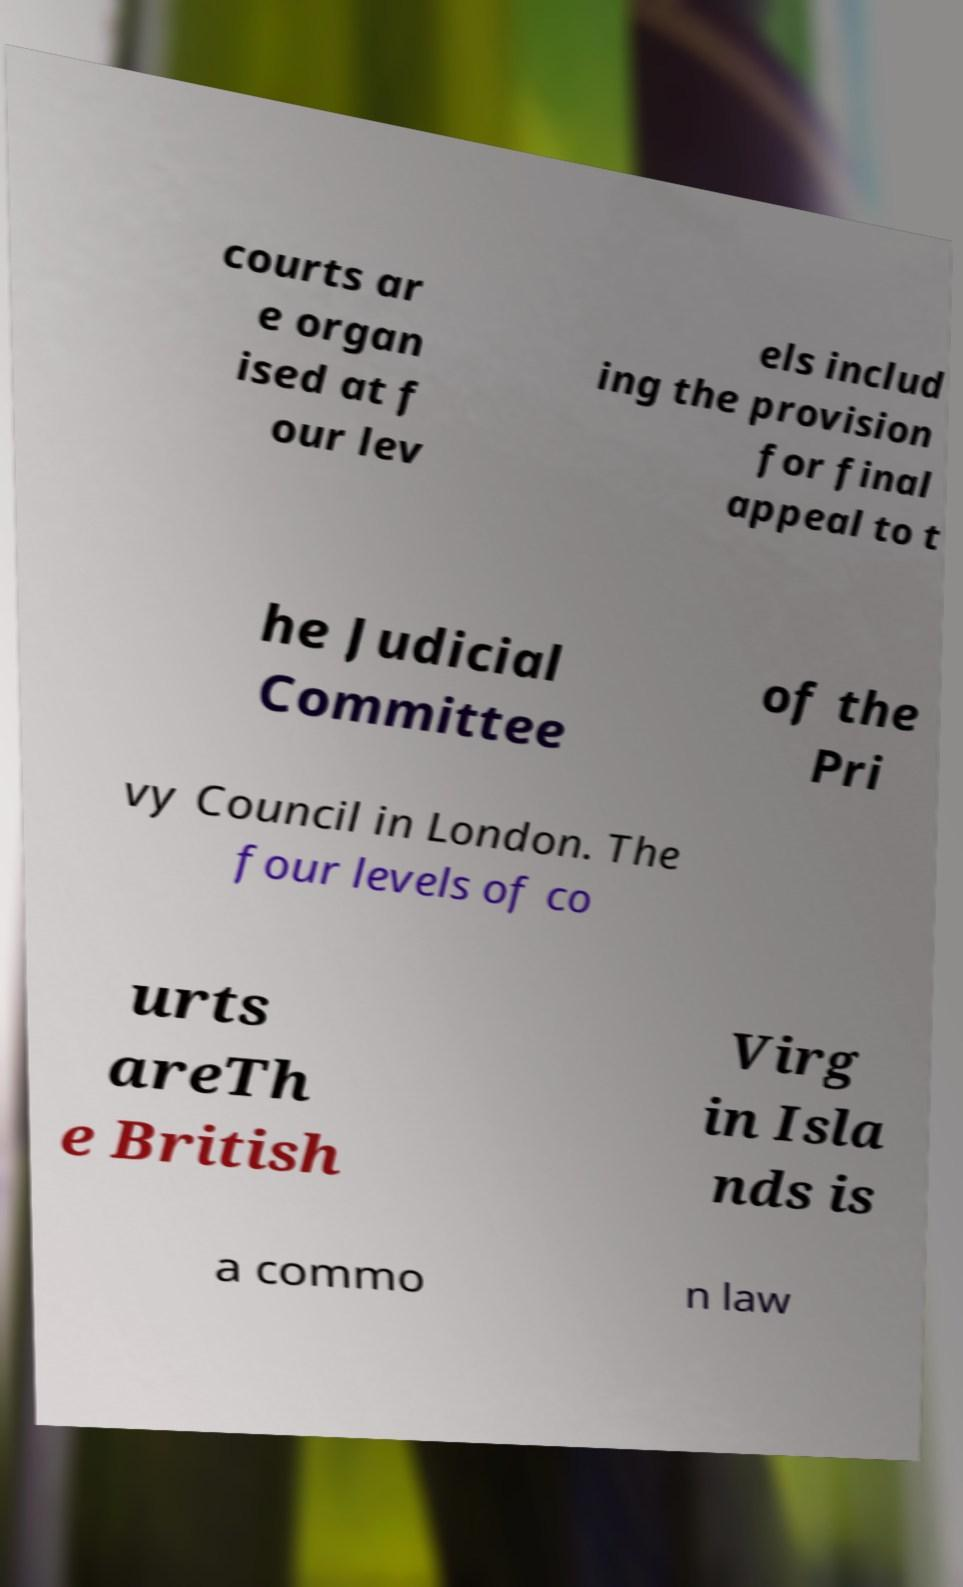I need the written content from this picture converted into text. Can you do that? courts ar e organ ised at f our lev els includ ing the provision for final appeal to t he Judicial Committee of the Pri vy Council in London. The four levels of co urts areTh e British Virg in Isla nds is a commo n law 